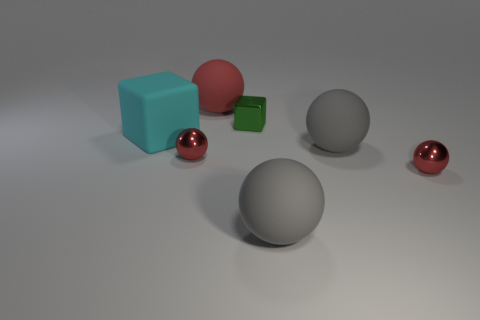What number of other objects are there of the same material as the big cyan thing? There are three objects in the image that appear to share the same matte plastic material as the big cyan cube: a smaller green cube and two spheres, one large and one small. 